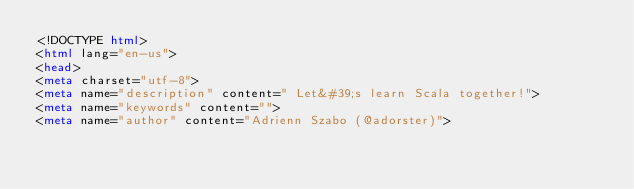Convert code to text. <code><loc_0><loc_0><loc_500><loc_500><_HTML_><!DOCTYPE html>
<html lang="en-us">
<head>
<meta charset="utf-8">
<meta name="description" content=" Let&#39;s learn Scala together!">
<meta name="keywords" content="">
<meta name="author" content="Adrienn Szabo (@adorster)"></code> 